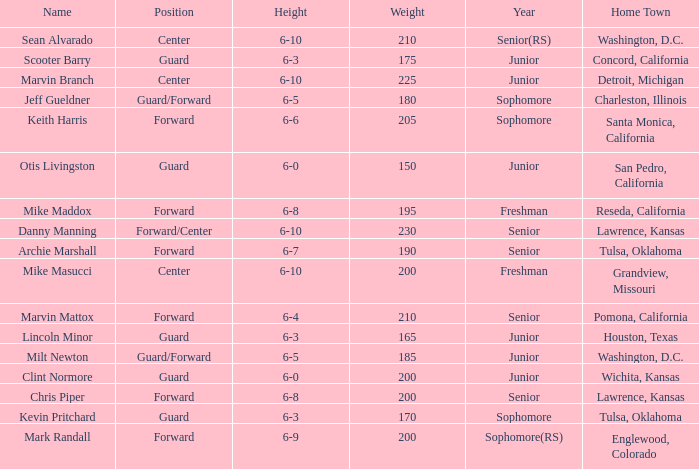Can you tell me the Name that has the Height of 6-5, and the Year of junior? Milt Newton. I'm looking to parse the entire table for insights. Could you assist me with that? {'header': ['Name', 'Position', 'Height', 'Weight', 'Year', 'Home Town'], 'rows': [['Sean Alvarado', 'Center', '6-10', '210', 'Senior(RS)', 'Washington, D.C.'], ['Scooter Barry', 'Guard', '6-3', '175', 'Junior', 'Concord, California'], ['Marvin Branch', 'Center', '6-10', '225', 'Junior', 'Detroit, Michigan'], ['Jeff Gueldner', 'Guard/Forward', '6-5', '180', 'Sophomore', 'Charleston, Illinois'], ['Keith Harris', 'Forward', '6-6', '205', 'Sophomore', 'Santa Monica, California'], ['Otis Livingston', 'Guard', '6-0', '150', 'Junior', 'San Pedro, California'], ['Mike Maddox', 'Forward', '6-8', '195', 'Freshman', 'Reseda, California'], ['Danny Manning', 'Forward/Center', '6-10', '230', 'Senior', 'Lawrence, Kansas'], ['Archie Marshall', 'Forward', '6-7', '190', 'Senior', 'Tulsa, Oklahoma'], ['Mike Masucci', 'Center', '6-10', '200', 'Freshman', 'Grandview, Missouri'], ['Marvin Mattox', 'Forward', '6-4', '210', 'Senior', 'Pomona, California'], ['Lincoln Minor', 'Guard', '6-3', '165', 'Junior', 'Houston, Texas'], ['Milt Newton', 'Guard/Forward', '6-5', '185', 'Junior', 'Washington, D.C.'], ['Clint Normore', 'Guard', '6-0', '200', 'Junior', 'Wichita, Kansas'], ['Chris Piper', 'Forward', '6-8', '200', 'Senior', 'Lawrence, Kansas'], ['Kevin Pritchard', 'Guard', '6-3', '170', 'Sophomore', 'Tulsa, Oklahoma'], ['Mark Randall', 'Forward', '6-9', '200', 'Sophomore(RS)', 'Englewood, Colorado']]} 